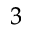<formula> <loc_0><loc_0><loc_500><loc_500>^ { 3 }</formula> 